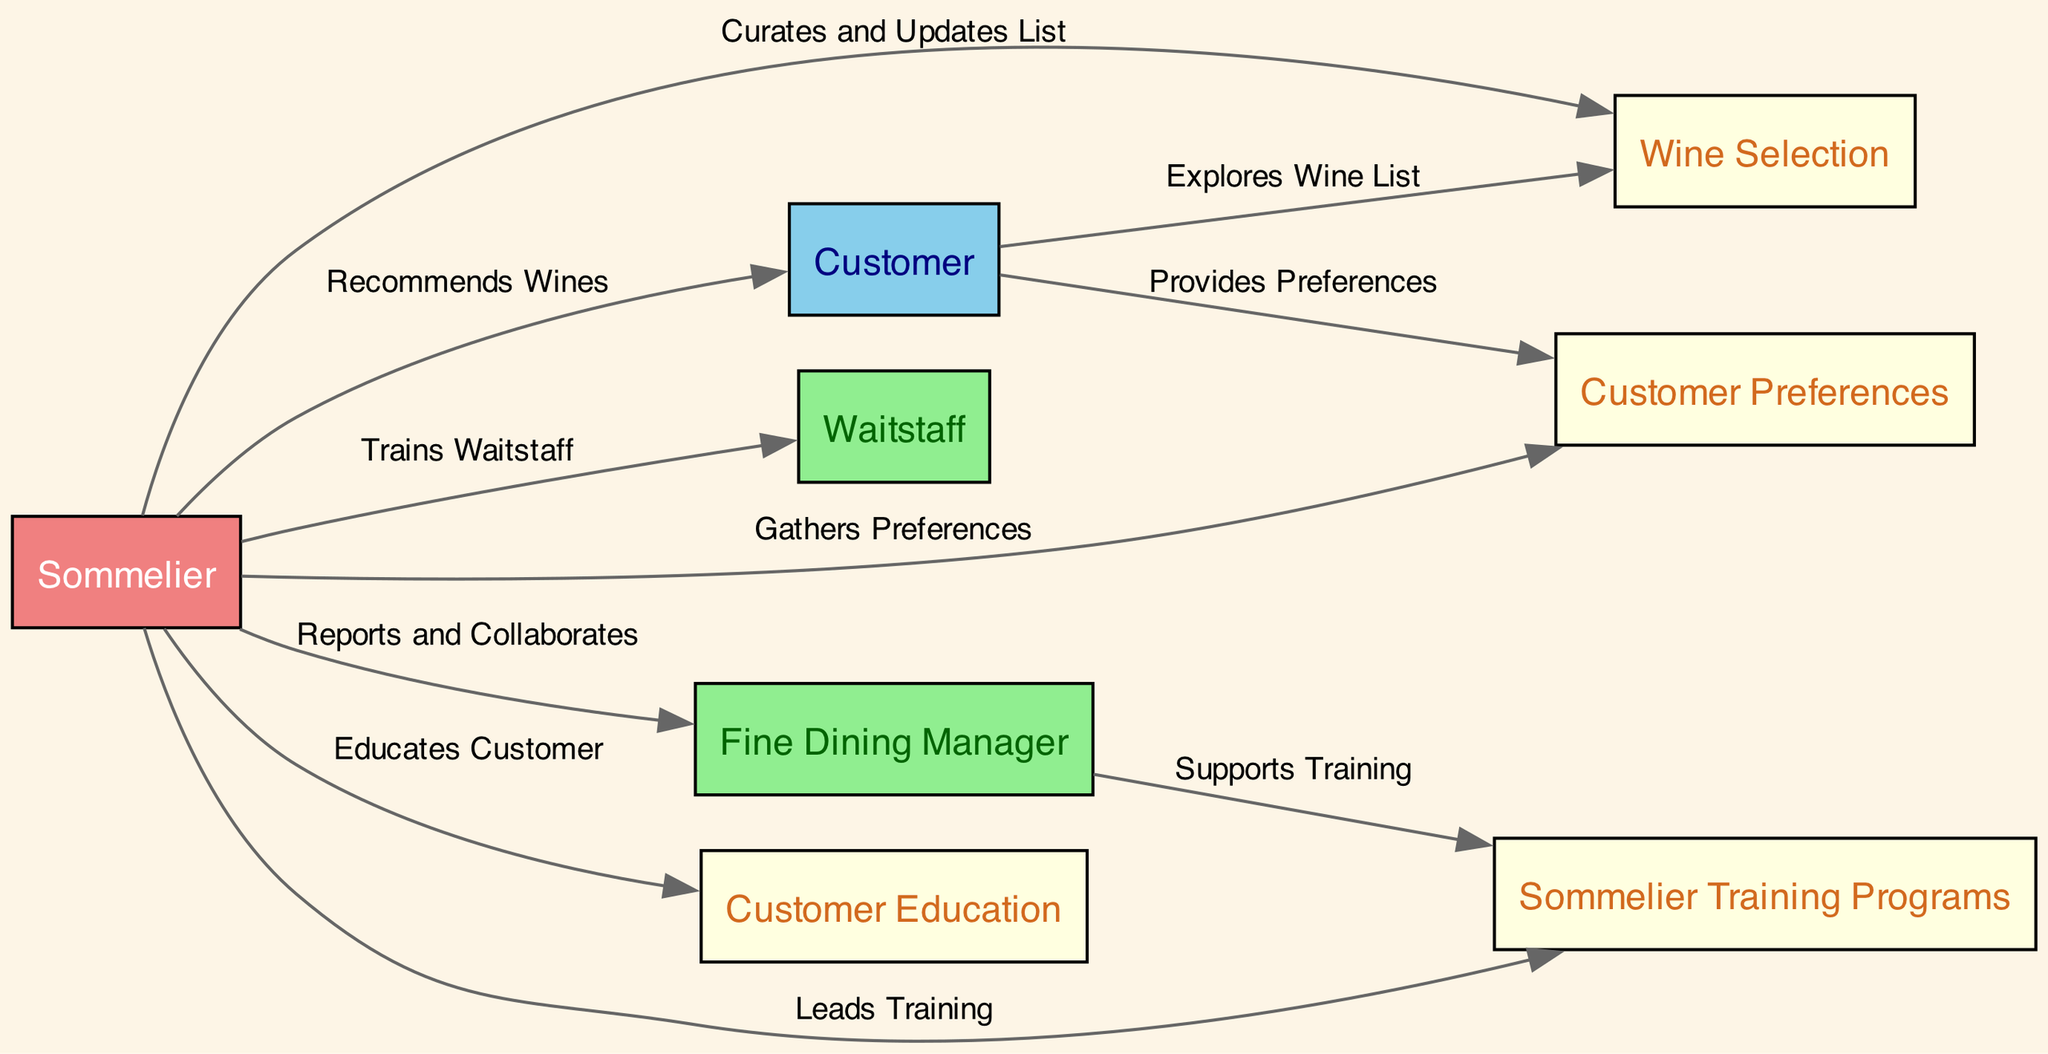What is the primary role of the Sommelier in this diagram? The Sommelier is depicted as a central figure, where the edges showcase their interactions with various entities, primarily recommending wines to customers.
Answer: Sommelier How many nodes are present in the diagram? By counting the distinct entities listed in the nodes section, we find there are eight individual nodes present in the diagram.
Answer: 8 What relationship does the Fine Dining Manager share with the Sommelier? The Fine Dining Manager collaborates with the Sommelier, as indicated by the edge labeled "Reports and Collaborates."
Answer: Reports and Collaborates Which node gathers customer preferences? The Sommelier gathers customer preferences, as illustrated by the edge connecting the Sommelier to Customer Preferences.
Answer: Sommelier What type of training does the Sommelier provide to others in the diagram? The Sommelier trains the Waitstaff, as shown in the edge labeled "Trains Waitstaff."
Answer: Trains Waitstaff Which node informs the Sommelier about the Customer’s choices? The Customer node provides preferences to the Sommelier, which is indicated by the edge labeled "Provides Preferences."
Answer: Provides Preferences How many edges originate from the Sommelier? The Sommelier has five edges originating from it, indicating its multiple interactions and relationships with other nodes.
Answer: 5 What is the connection between the Fine Dining Manager and Sommelier Training Programs? The Fine Dining Manager supports training programs, as represented by the edge labeled "Supports Training."
Answer: Supports Training What action does the Sommelier take regarding the Wine Selection? The Sommelier curates and updates the wine list, which is marked by the edge connecting them to the Wine Selection node.
Answer: Curates and Updates List 